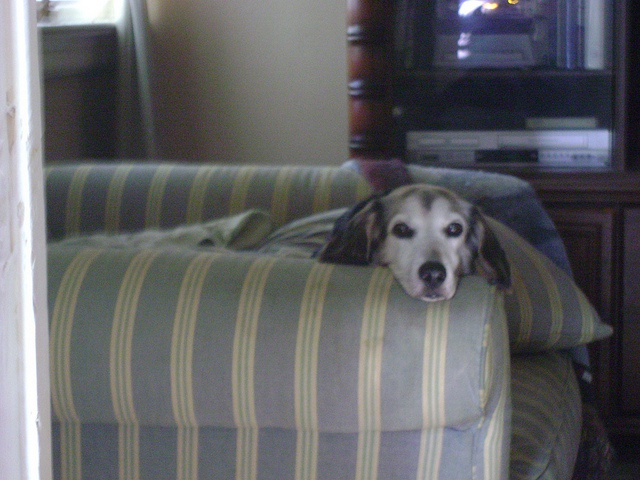Describe the objects in this image and their specific colors. I can see couch in lightgray, gray, darkgray, and black tones, tv in lightgray, black, gray, and navy tones, and dog in lightgray, black, gray, and darkgray tones in this image. 